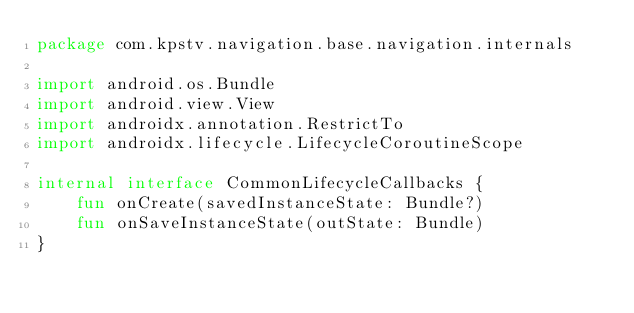<code> <loc_0><loc_0><loc_500><loc_500><_Kotlin_>package com.kpstv.navigation.base.navigation.internals

import android.os.Bundle
import android.view.View
import androidx.annotation.RestrictTo
import androidx.lifecycle.LifecycleCoroutineScope

internal interface CommonLifecycleCallbacks {
    fun onCreate(savedInstanceState: Bundle?)
    fun onSaveInstanceState(outState: Bundle)
}</code> 